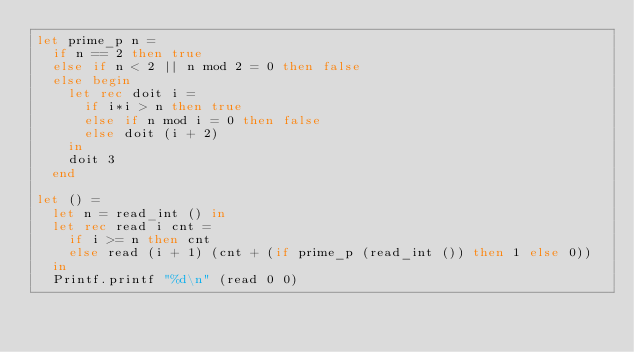<code> <loc_0><loc_0><loc_500><loc_500><_OCaml_>let prime_p n =
  if n == 2 then true
  else if n < 2 || n mod 2 = 0 then false
  else begin
    let rec doit i =
      if i*i > n then true
      else if n mod i = 0 then false
      else doit (i + 2)
    in
    doit 3
  end

let () =
  let n = read_int () in
  let rec read i cnt =
    if i >= n then cnt
    else read (i + 1) (cnt + (if prime_p (read_int ()) then 1 else 0))
  in
  Printf.printf "%d\n" (read 0 0)</code> 